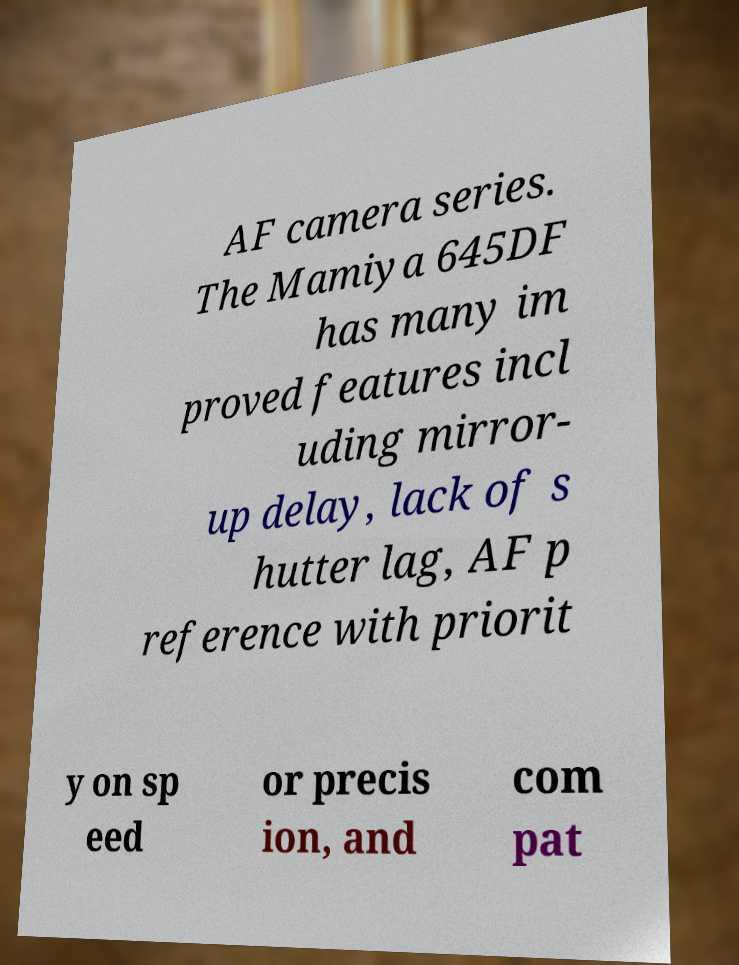What messages or text are displayed in this image? I need them in a readable, typed format. AF camera series. The Mamiya 645DF has many im proved features incl uding mirror- up delay, lack of s hutter lag, AF p reference with priorit y on sp eed or precis ion, and com pat 